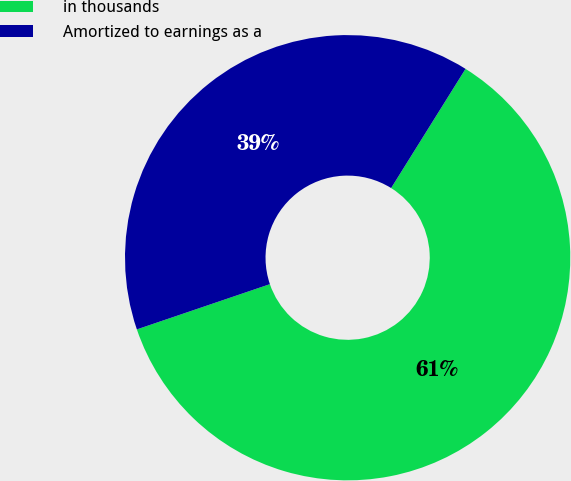Convert chart to OTSL. <chart><loc_0><loc_0><loc_500><loc_500><pie_chart><fcel>in thousands<fcel>Amortized to earnings as a<nl><fcel>60.9%<fcel>39.1%<nl></chart> 